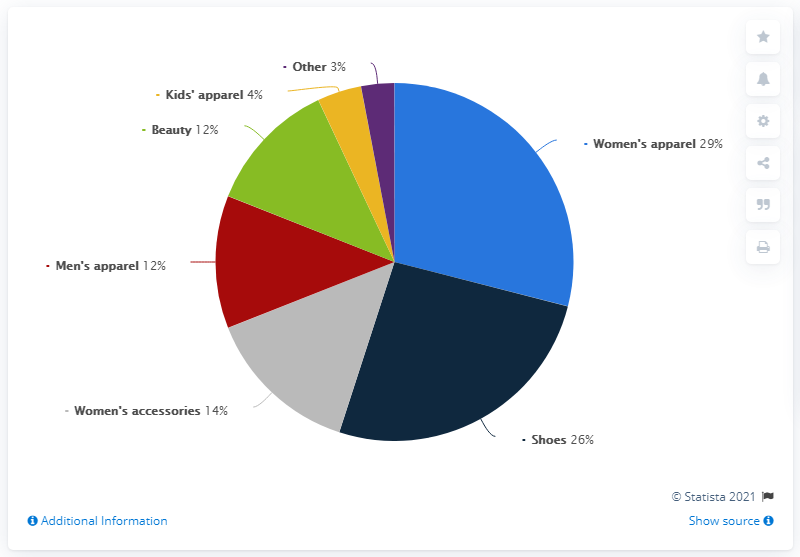Highlight a few significant elements in this photo. Women's accessories and apparel together contribute approximately 43% to the overall market. The women's apparel sector is the sector that contributes the largest share. 